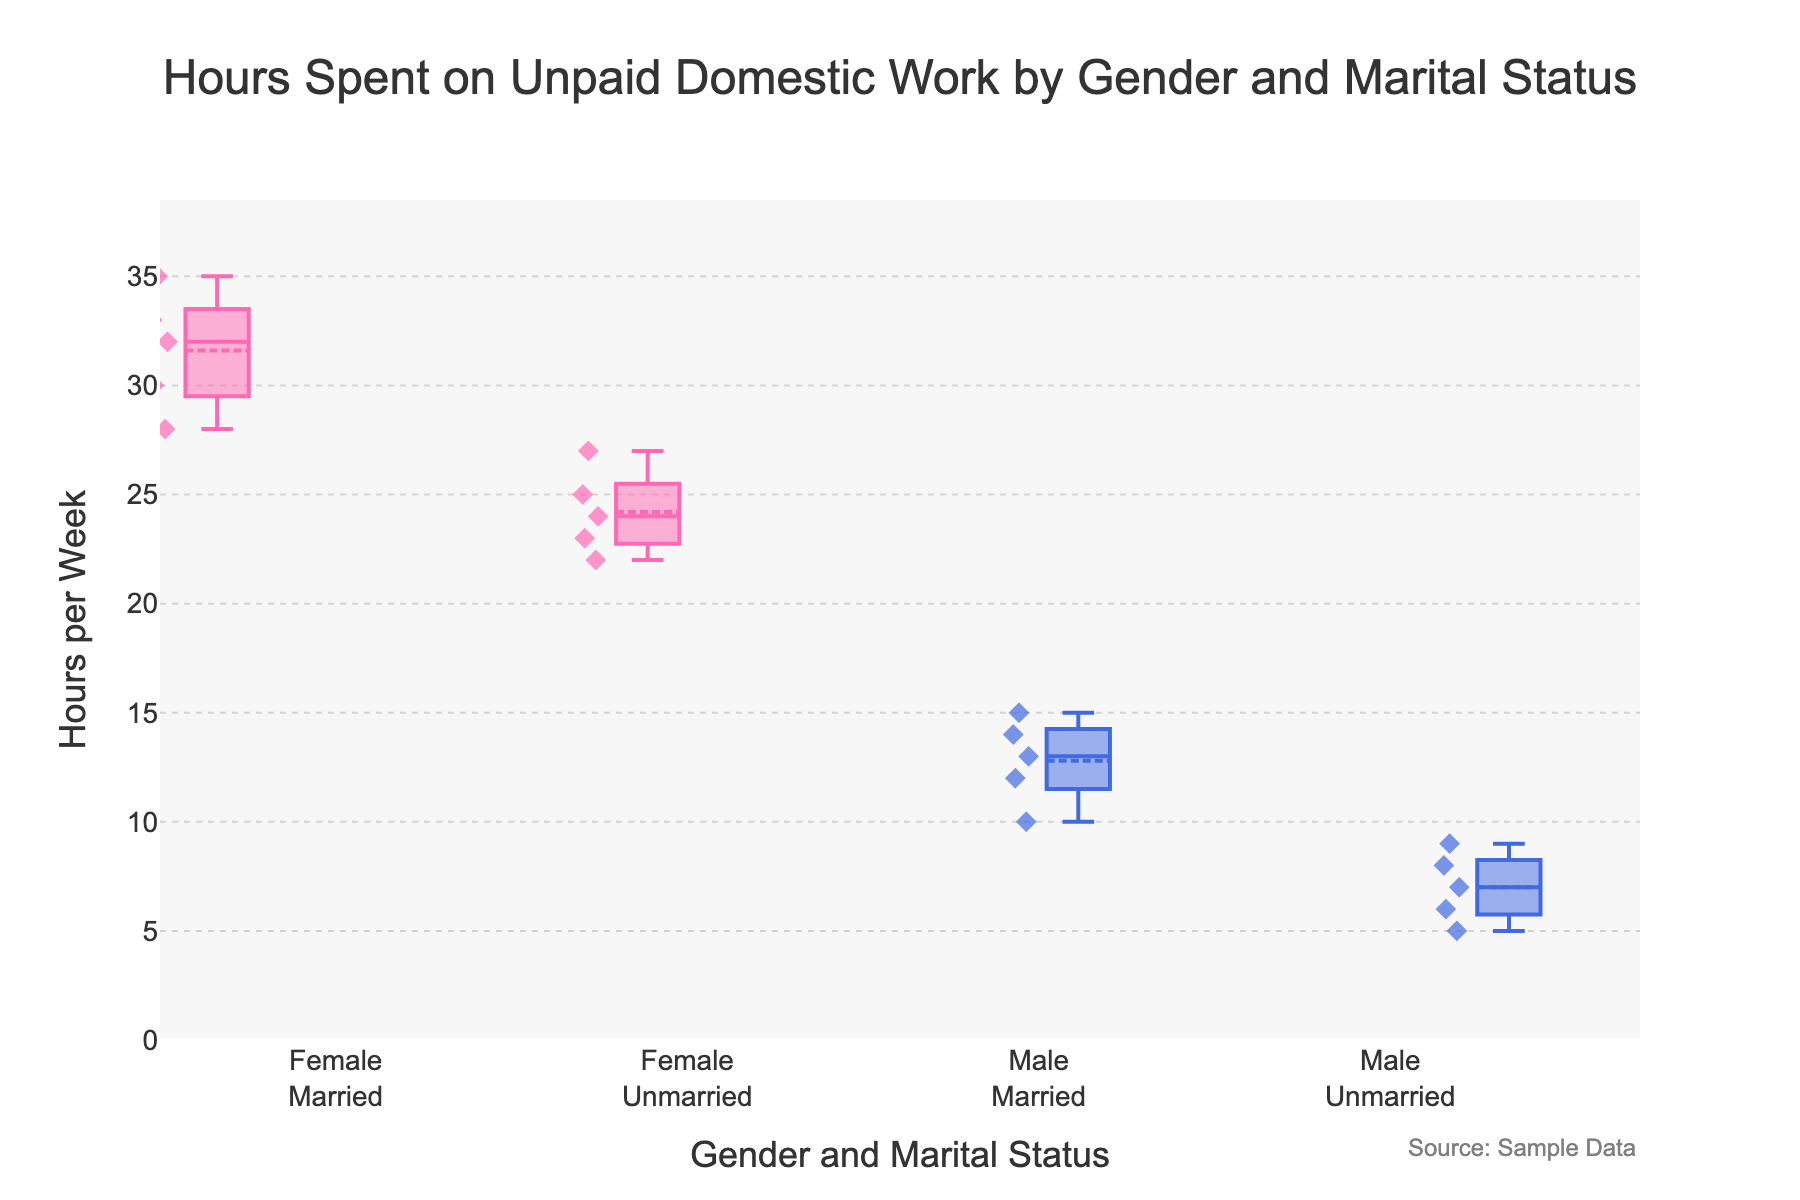What's the title of the figure? The title of the figure is written at the top and centrally aligned.
Answer: Hours Spent on Unpaid Domestic Work by Gender and Marital Status What is the range of hours spent on unpaid domestic work? The range can be seen from the y-axis. It starts from 0 and goes up to a bit above 35.
Answer: 0 to 35 hours Which gender spends more time on unpaid domestic work on average? By looking at the position of the boxes, the boxes for females are generally higher on the y-axis than those for males.
Answer: Female Among married individuals, which gender has higher variability in hours spent on unpaid domestic work? The box for "Female Married" is taller, indicating a wider interquartile range compared to "Male Married".
Answer: Female What is the median value of hours spent on unpaid domestic work for unmarried males? The median is indicated by the line inside the "Male Unmarried" box plot. This line appears at the value 7.
Answer: 7 Are there any outliers in the data? Outliers are typically represented as points outside the whiskers in a box plot. There are no points outside of the whiskers in any group.
Answer: No Compare the median hours spent on unpaid domestic work between married females and married males. The median is indicated by the line inside each box plot. The median for "Female Married" appears at about 32, and for "Male Married", it appears at 13.
Answer: Female Married: 32, Male Married: 13 What is the mean value of hours spent on unpaid domestic work for unmarried females? The mean is marked by a dashed line within each box. For "Female Unmarried", it appears to be slightly above 24.
Answer: Slightly above 24 Which group has the lowest recorded hours spent on unpaid domestic work? The lowest value is identified by the bottom whisker of the box plots. The lowest whisker for "Male Unmarried" reaches down to 5.
Answer: Male Unmarried Is there any group where the average hours spent on unpaid domestic work is less than 10? The average can be found by looking at the dashed line. For "Male Unmarried," the dashed line (mean) appears below 10.
Answer: Yes, Male Unmarried 